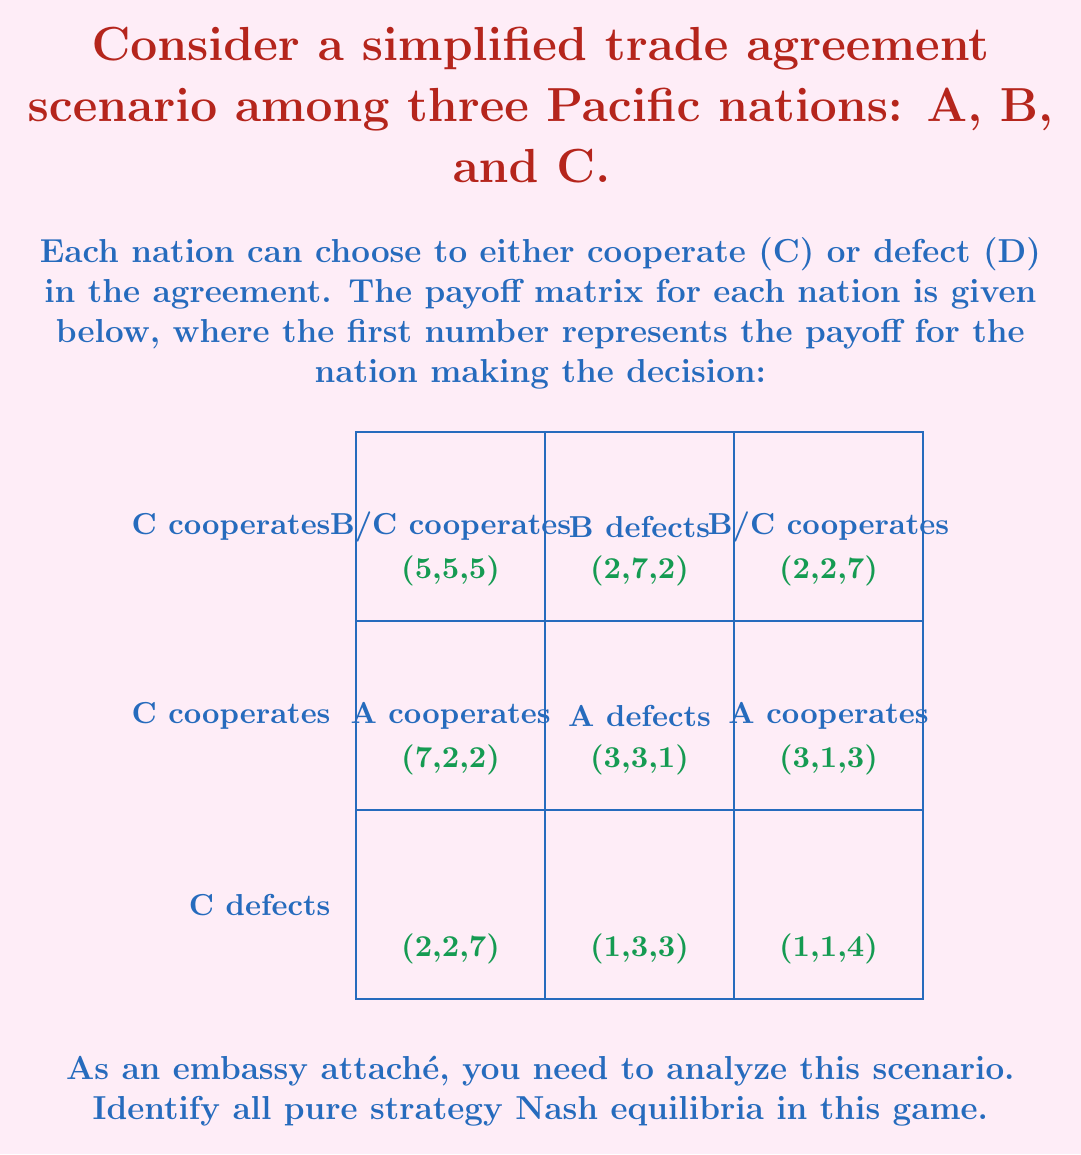What is the answer to this math problem? To find the pure strategy Nash equilibria, we need to examine each possible strategy combination and determine if any player has an incentive to unilaterally deviate from their strategy.

1. First, let's consider (C,C,C):
   - If A deviates to D, payoff increases from 5 to 7
   - Therefore, (C,C,C) is not a Nash equilibrium

2. Consider (D,C,C):
   - If B deviates to D, payoff increases from 2 to 3
   - Therefore, (D,C,C) is not a Nash equilibrium

3. Consider (C,D,C):
   - If A deviates to D, payoff increases from 2 to 3
   - Therefore, (C,D,C) is not a Nash equilibrium

4. Consider (C,C,D):
   - If A deviates to D, payoff increases from 2 to 3
   - Therefore, (C,C,D) is not a Nash equilibrium

5. Consider (D,D,C):
   - If C deviates to D, payoff increases from 1 to 3
   - Therefore, (D,D,C) is not a Nash equilibrium

6. Consider (D,C,D):
   - If B deviates to D, payoff increases from 1 to 3
   - Therefore, (D,C,D) is not a Nash equilibrium

7. Consider (C,D,D):
   - If A deviates to D, payoff increases from 1 to 3
   - Therefore, (C,D,D) is not a Nash equilibrium

8. Finally, consider (D,D,D):
   - If A deviates to C, payoff decreases from 3 to 2
   - If B deviates to C, payoff decreases from 3 to 2
   - If C deviates to C, payoff decreases from 3 to 2
   - No player has an incentive to unilaterally deviate

Therefore, the only pure strategy Nash equilibrium in this game is (D,D,D).

This result demonstrates the "Prisoner's Dilemma" nature of multilateral trade agreements. Despite the fact that all nations would be better off cooperating (payoff of 5 each), the individual incentive to defect leads to a suboptimal equilibrium where all nations defect (payoff of 3 each).
Answer: (D,D,D) 